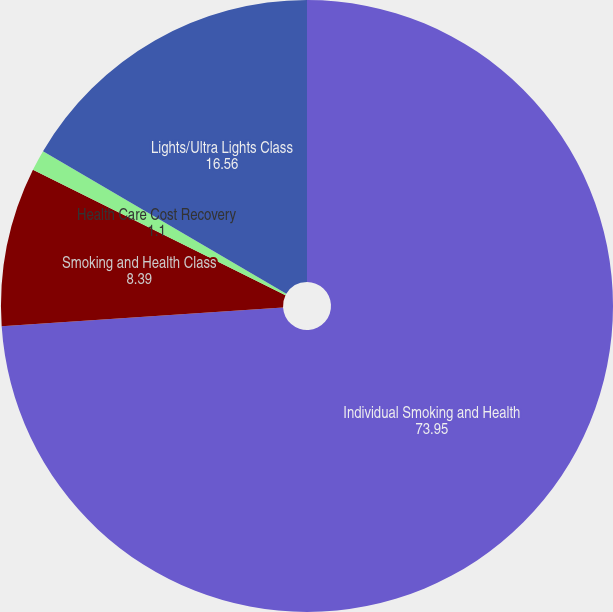Convert chart to OTSL. <chart><loc_0><loc_0><loc_500><loc_500><pie_chart><fcel>Individual Smoking and Health<fcel>Smoking and Health Class<fcel>Health Care Cost Recovery<fcel>Lights/Ultra Lights Class<nl><fcel>73.95%<fcel>8.39%<fcel>1.1%<fcel>16.56%<nl></chart> 